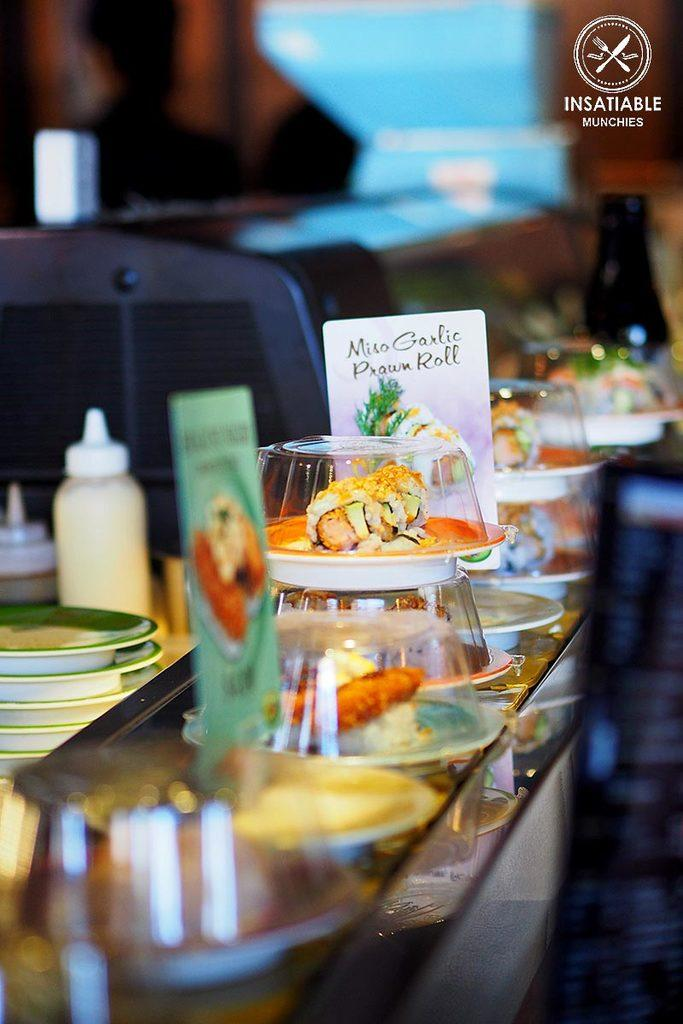What type of dishware can be seen in the image? There are plates and bowls in the image. What else is present in the image besides dishware? There is a bottle in the image. What is inside the bowls in the image? The bowls contain food items. Can you describe the stream flowing near the plates in the image? There is no stream present in the image; it only features plates, bowls, and a bottle. What type of apple can be seen in the image? There is no apple present in the image. 